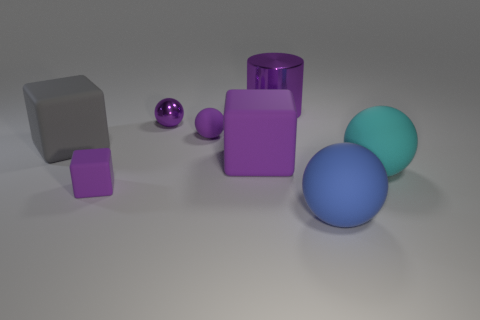Add 1 small red objects. How many objects exist? 9 Subtract all cubes. How many objects are left? 5 Subtract all small gray metal spheres. Subtract all large metallic things. How many objects are left? 7 Add 5 blue matte balls. How many blue matte balls are left? 6 Add 4 cyan blocks. How many cyan blocks exist? 4 Subtract 0 red blocks. How many objects are left? 8 